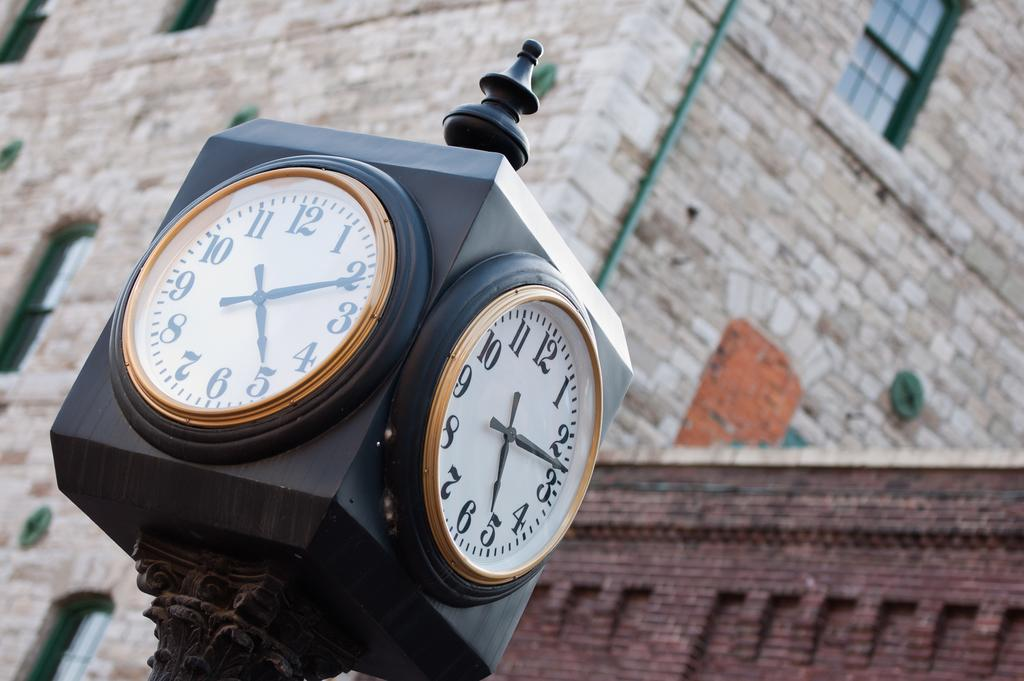Provide a one-sentence caption for the provided image. A large clock that is displaying the time of 5:11. 